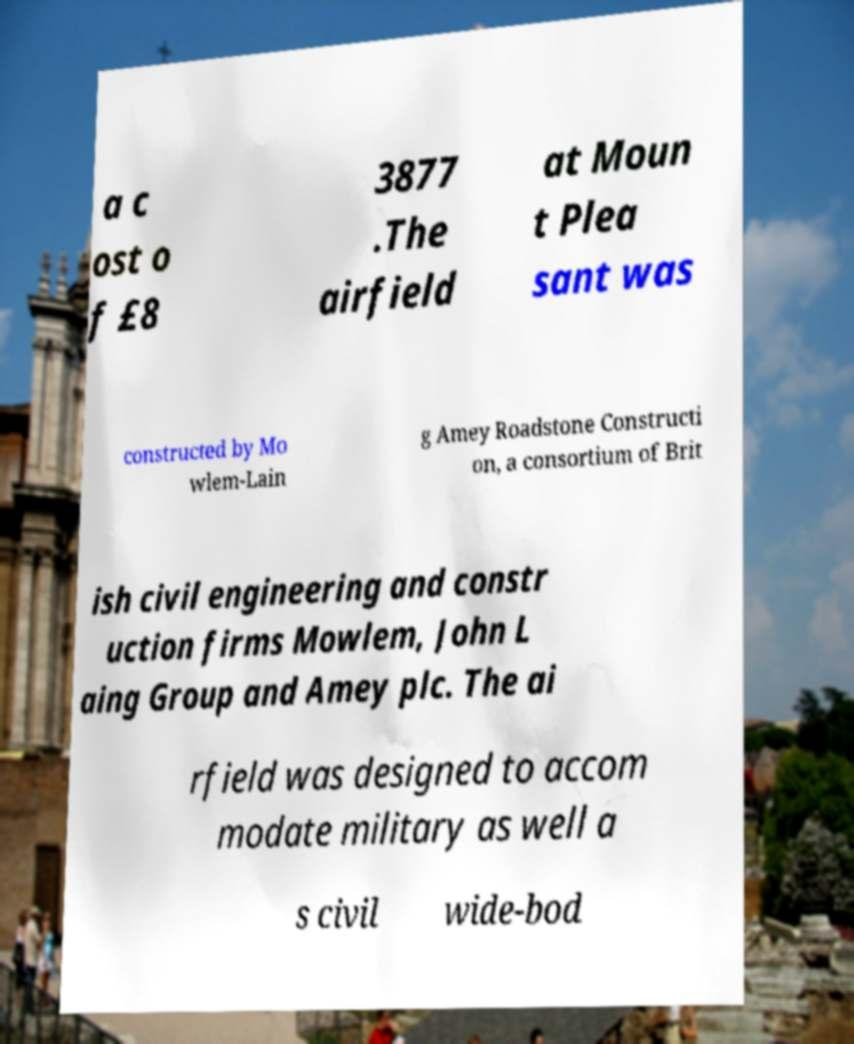For documentation purposes, I need the text within this image transcribed. Could you provide that? a c ost o f £8 3877 .The airfield at Moun t Plea sant was constructed by Mo wlem-Lain g Amey Roadstone Constructi on, a consortium of Brit ish civil engineering and constr uction firms Mowlem, John L aing Group and Amey plc. The ai rfield was designed to accom modate military as well a s civil wide-bod 